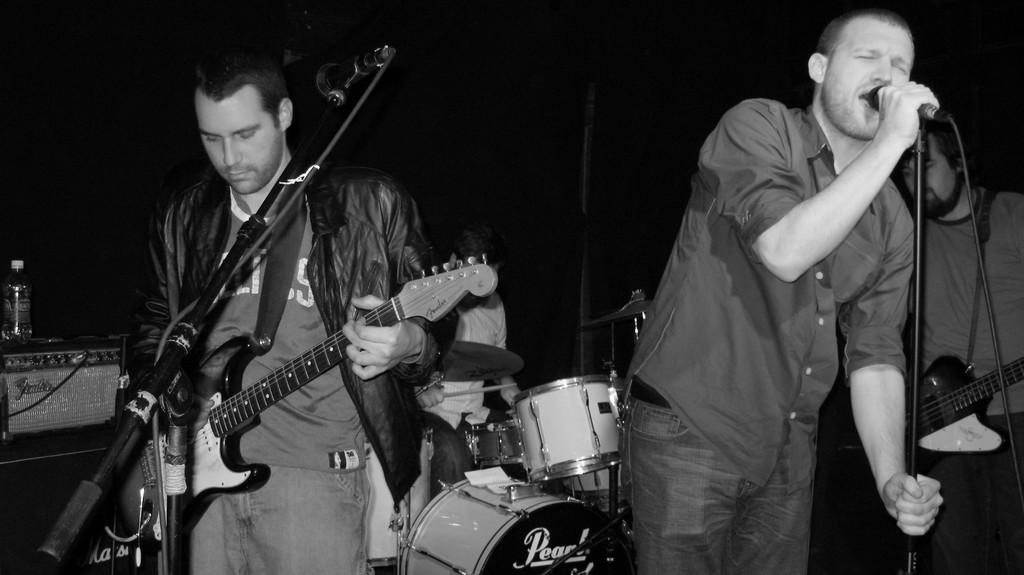How many musicians are present in the image? There are two musicians in the image. What is one of the musicians doing? One of the musicians is playing a guitar. What is the other musician doing? The other musician is singing through a microphone. Where is the shelf located in the image? There is no shelf present in the image. What type of self-portrait is the musician creating in the image? There is no self-portrait being created in the image; the musicians are playing music. 